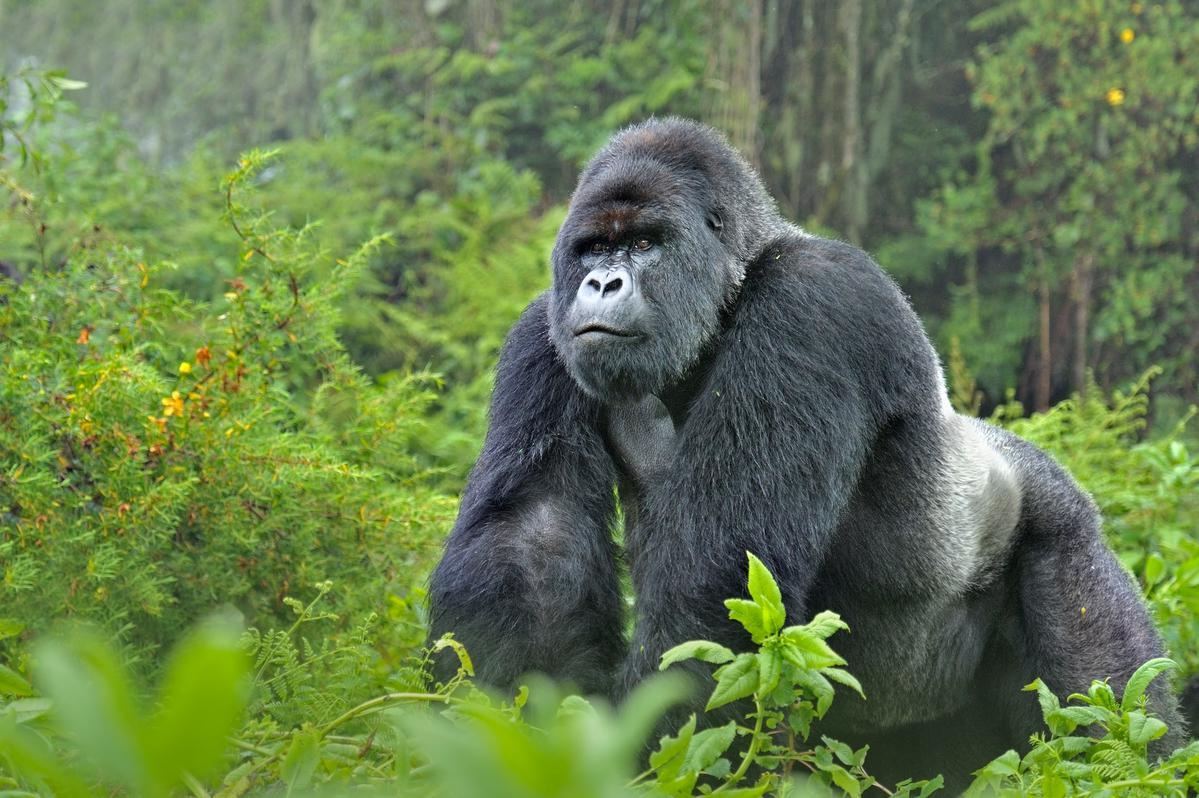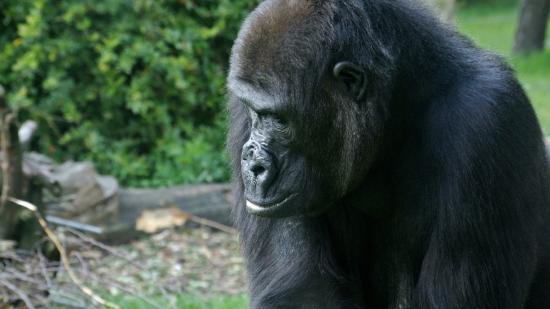The first image is the image on the left, the second image is the image on the right. For the images shown, is this caption "In total, the images depict at least four black-haired apes." true? Answer yes or no. No. 